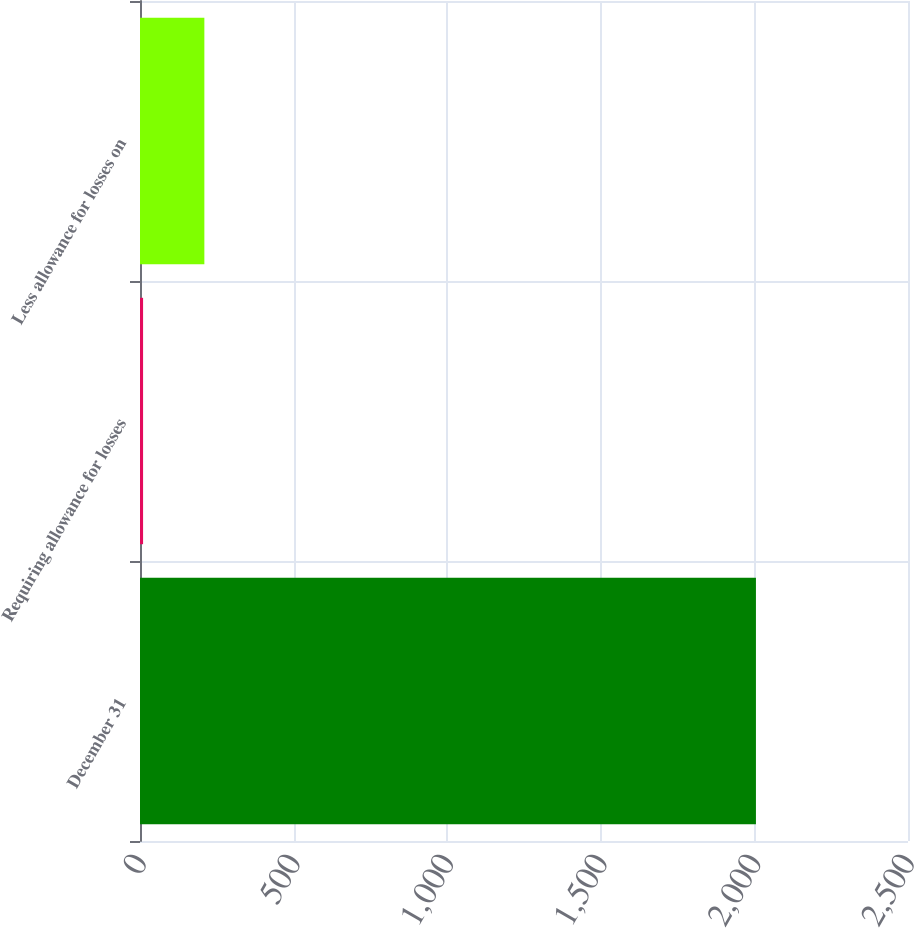<chart> <loc_0><loc_0><loc_500><loc_500><bar_chart><fcel>December 31<fcel>Requiring allowance for losses<fcel>Less allowance for losses on<nl><fcel>2005<fcel>10<fcel>209.5<nl></chart> 